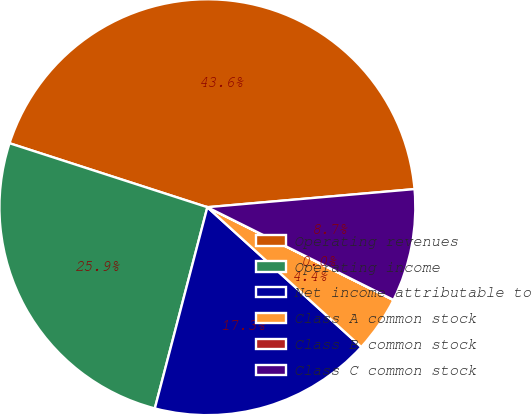Convert chart to OTSL. <chart><loc_0><loc_0><loc_500><loc_500><pie_chart><fcel>Operating revenues<fcel>Operating income<fcel>Net income attributable to<fcel>Class A common stock<fcel>Class B common stock<fcel>Class C common stock<nl><fcel>43.63%<fcel>25.91%<fcel>17.33%<fcel>4.37%<fcel>0.01%<fcel>8.74%<nl></chart> 